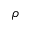Convert formula to latex. <formula><loc_0><loc_0><loc_500><loc_500>\rho</formula> 